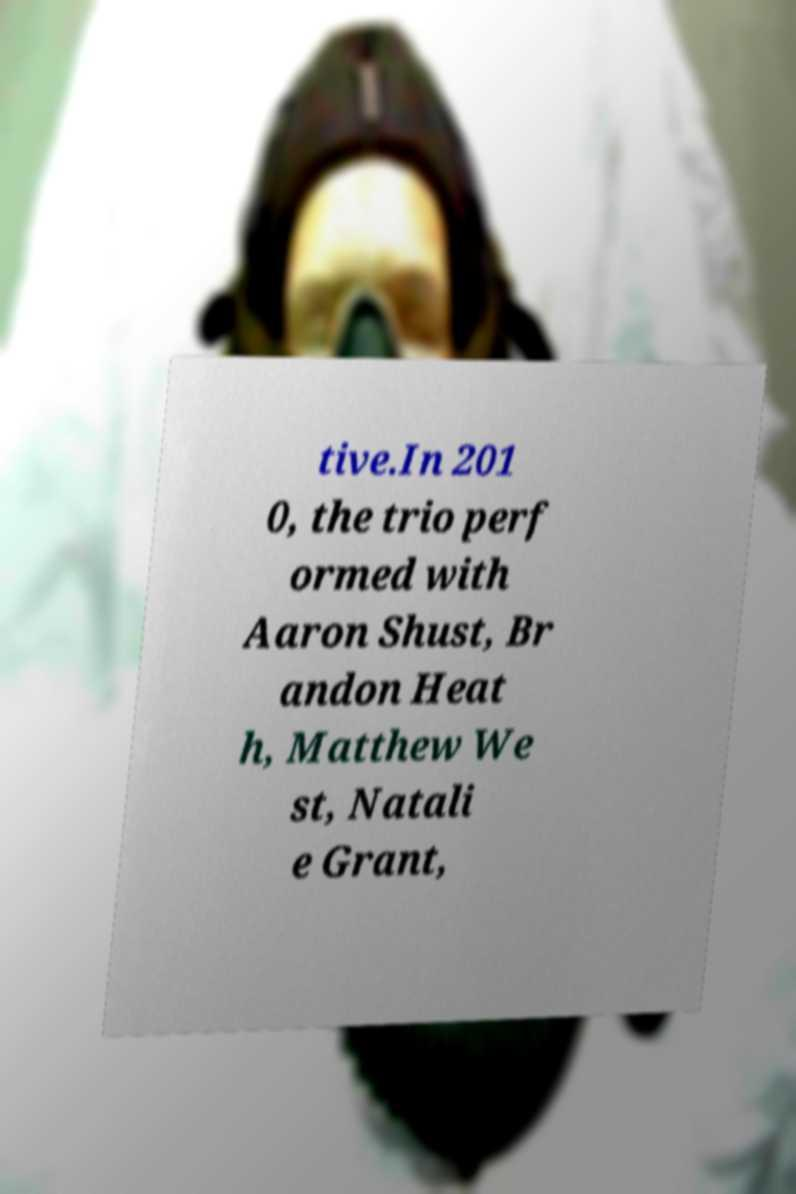Could you assist in decoding the text presented in this image and type it out clearly? tive.In 201 0, the trio perf ormed with Aaron Shust, Br andon Heat h, Matthew We st, Natali e Grant, 